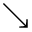Convert formula to latex. <formula><loc_0><loc_0><loc_500><loc_500>\searrow</formula> 